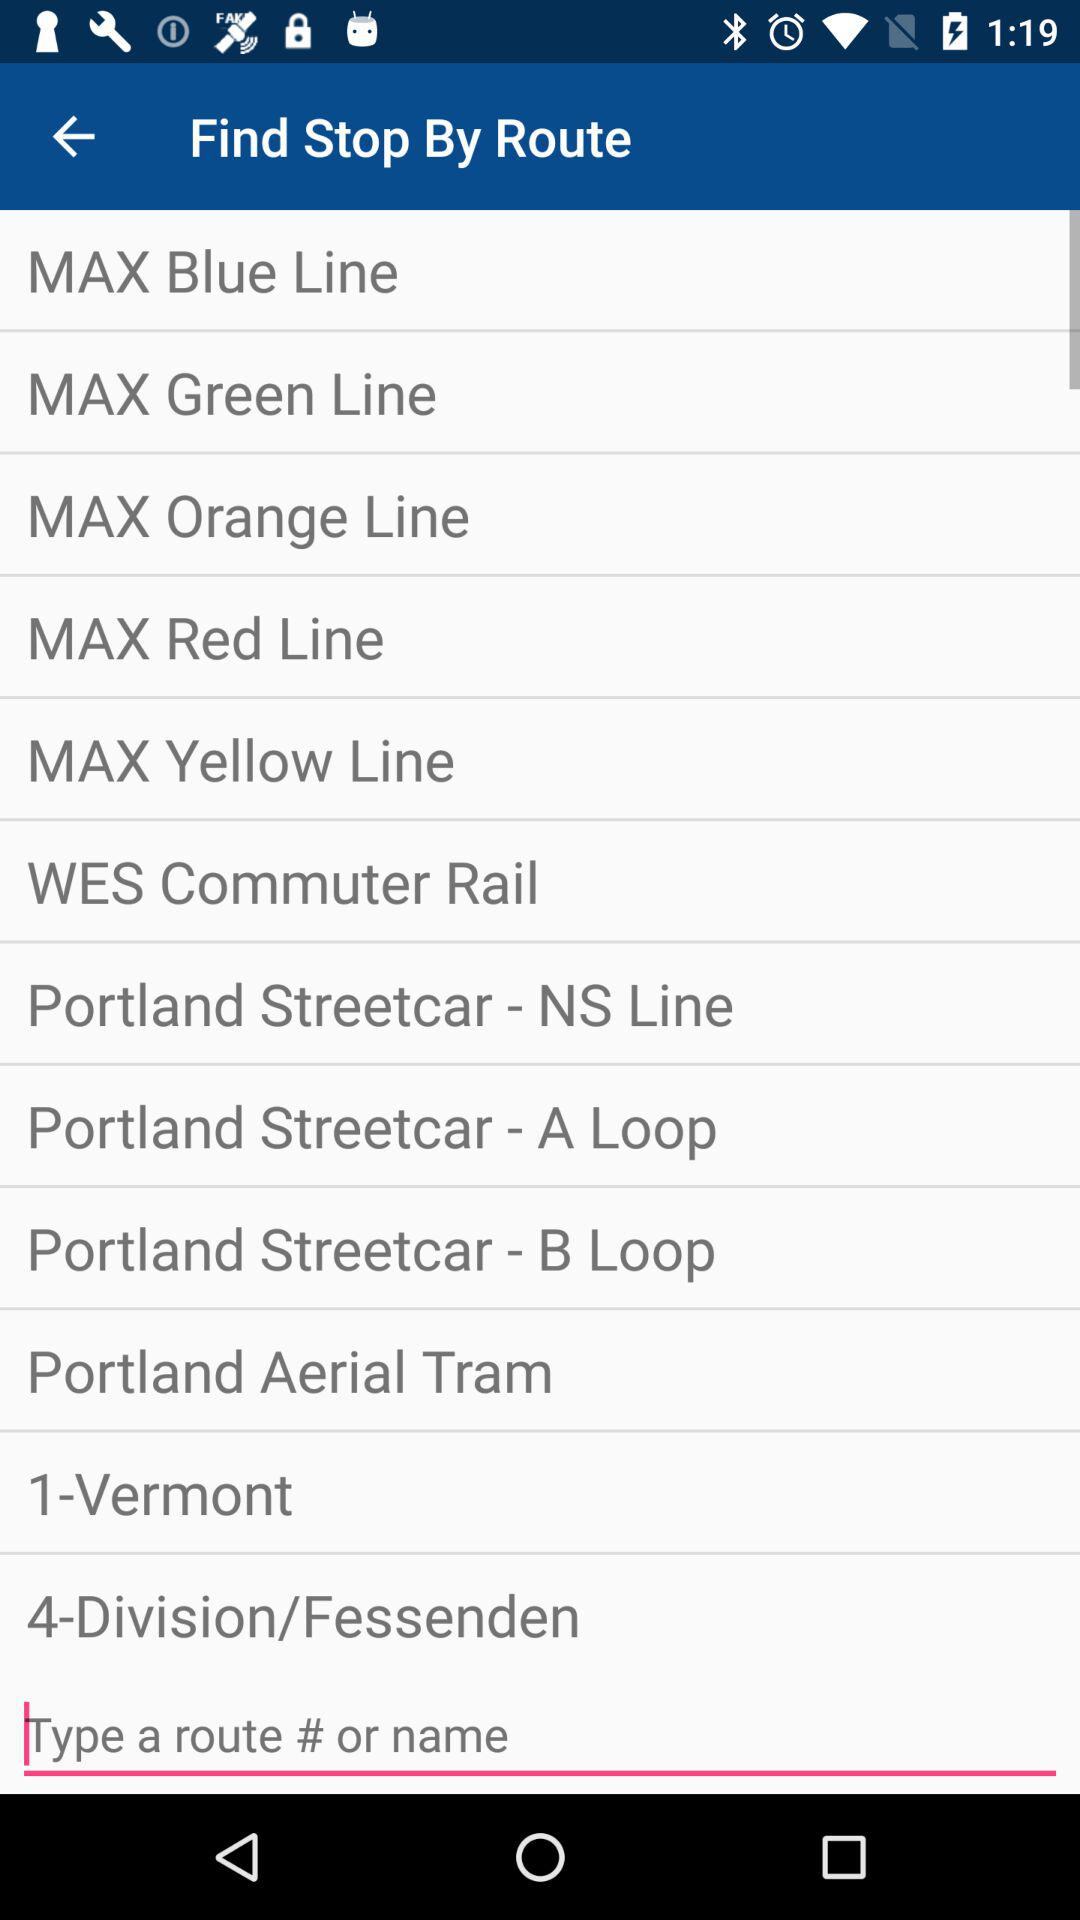How many MAX lines are there?
Answer the question using a single word or phrase. 5 